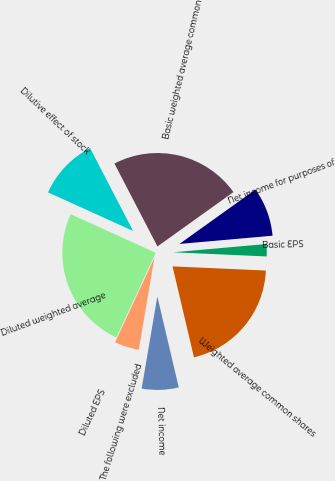<chart> <loc_0><loc_0><loc_500><loc_500><pie_chart><fcel>Net income<fcel>Weighted average common shares<fcel>Basic EPS<fcel>Net income for purposes of<fcel>Basic weighted average common<fcel>Dilutive effect of stock<fcel>Diluted weighted average<fcel>Diluted EPS<fcel>The following were excluded<nl><fcel>6.36%<fcel>20.61%<fcel>2.12%<fcel>8.48%<fcel>22.73%<fcel>10.6%<fcel>24.85%<fcel>0.0%<fcel>4.24%<nl></chart> 